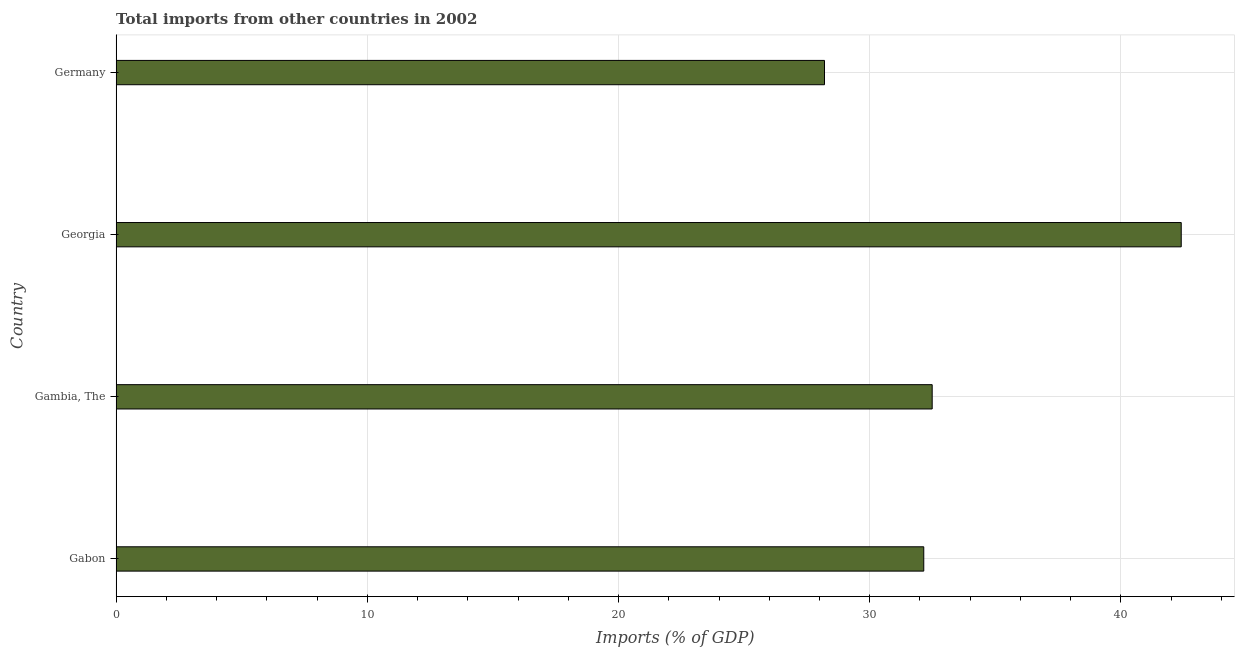What is the title of the graph?
Give a very brief answer. Total imports from other countries in 2002. What is the label or title of the X-axis?
Ensure brevity in your answer.  Imports (% of GDP). What is the total imports in Germany?
Ensure brevity in your answer.  28.2. Across all countries, what is the maximum total imports?
Make the answer very short. 42.4. Across all countries, what is the minimum total imports?
Give a very brief answer. 28.2. In which country was the total imports maximum?
Your answer should be compact. Georgia. What is the sum of the total imports?
Make the answer very short. 135.23. What is the difference between the total imports in Gabon and Georgia?
Provide a short and direct response. -10.25. What is the average total imports per country?
Your response must be concise. 33.81. What is the median total imports?
Your response must be concise. 32.32. In how many countries, is the total imports greater than 34 %?
Your answer should be compact. 1. What is the ratio of the total imports in Georgia to that in Germany?
Provide a short and direct response. 1.5. Is the difference between the total imports in Gambia, The and Georgia greater than the difference between any two countries?
Your response must be concise. No. What is the difference between the highest and the second highest total imports?
Offer a very short reply. 9.91. How many countries are there in the graph?
Offer a terse response. 4. What is the difference between two consecutive major ticks on the X-axis?
Offer a terse response. 10. Are the values on the major ticks of X-axis written in scientific E-notation?
Your response must be concise. No. What is the Imports (% of GDP) in Gabon?
Give a very brief answer. 32.15. What is the Imports (% of GDP) of Gambia, The?
Offer a terse response. 32.49. What is the Imports (% of GDP) of Georgia?
Ensure brevity in your answer.  42.4. What is the Imports (% of GDP) in Germany?
Provide a short and direct response. 28.2. What is the difference between the Imports (% of GDP) in Gabon and Gambia, The?
Your answer should be compact. -0.34. What is the difference between the Imports (% of GDP) in Gabon and Georgia?
Provide a short and direct response. -10.25. What is the difference between the Imports (% of GDP) in Gabon and Germany?
Your answer should be very brief. 3.95. What is the difference between the Imports (% of GDP) in Gambia, The and Georgia?
Offer a terse response. -9.91. What is the difference between the Imports (% of GDP) in Gambia, The and Germany?
Keep it short and to the point. 4.29. What is the difference between the Imports (% of GDP) in Georgia and Germany?
Offer a very short reply. 14.2. What is the ratio of the Imports (% of GDP) in Gabon to that in Gambia, The?
Provide a short and direct response. 0.99. What is the ratio of the Imports (% of GDP) in Gabon to that in Georgia?
Your answer should be very brief. 0.76. What is the ratio of the Imports (% of GDP) in Gabon to that in Germany?
Offer a very short reply. 1.14. What is the ratio of the Imports (% of GDP) in Gambia, The to that in Georgia?
Provide a short and direct response. 0.77. What is the ratio of the Imports (% of GDP) in Gambia, The to that in Germany?
Give a very brief answer. 1.15. What is the ratio of the Imports (% of GDP) in Georgia to that in Germany?
Offer a very short reply. 1.5. 